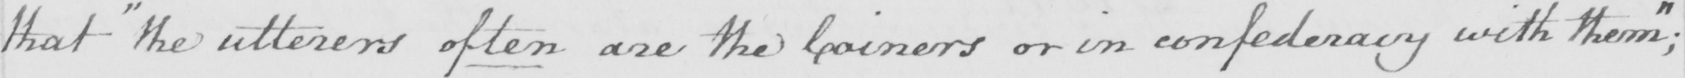What is written in this line of handwriting? that  " the utterers often are the Coiners or in confederacy with them "  ; 